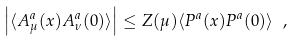Convert formula to latex. <formula><loc_0><loc_0><loc_500><loc_500>\left | \langle A ^ { a } _ { \mu } ( x ) A ^ { a } _ { \nu } ( 0 ) \rangle \right | \leq Z ( \mu ) \langle P ^ { a } ( x ) P ^ { a } ( 0 ) \rangle \ ,</formula> 